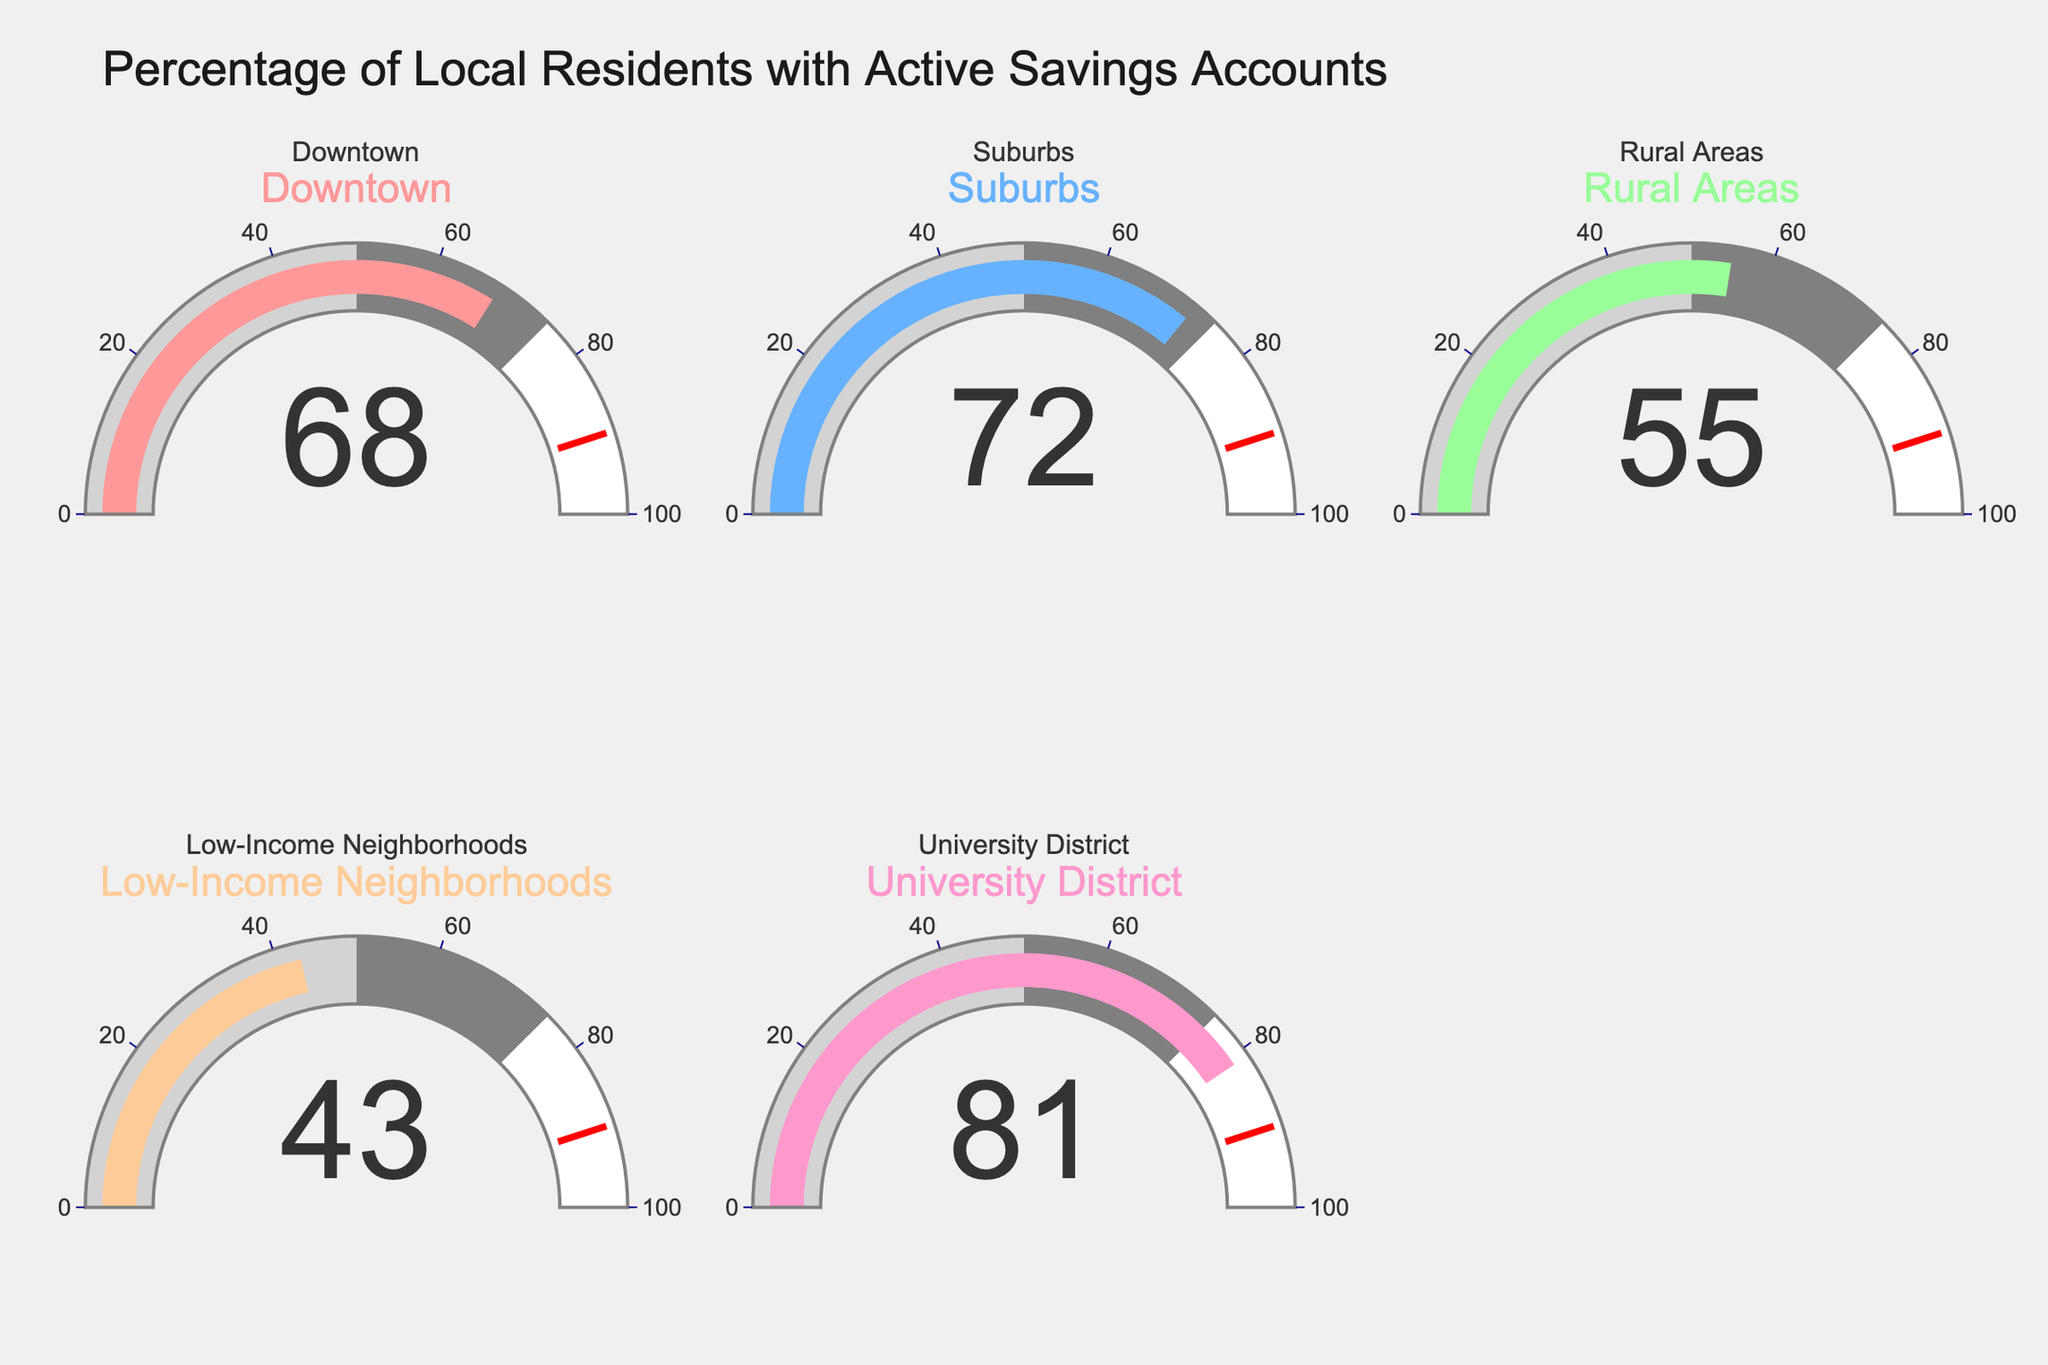What's the title of the figure? The title is located at the top of the figure, indicating the overall subject.
Answer: Percentage of Local Residents with Active Savings Accounts How many locations are displayed in the figure? We count the number of gauge charts, each representing a different location.
Answer: 5 Which location has the highest percentage of residents with active savings accounts? By examining each gauge's number, we compare all values to identify the highest one.
Answer: University District What is the percentage of residents with active savings accounts in Rural Areas? Look at the gauge corresponding to Rural Areas and read the number.
Answer: 55 What is the difference in percentage of active savings accounts between the Suburbs and Downtown? Subtract the percentage value of Downtown from that of the Suburbs.
Answer: 4 Which location has the lowest percentage of residents with active savings accounts? Compare all values on the gauges and identify the lowest one.
Answer: Low-Income Neighborhoods What is the average percentage of residents with active savings accounts across all locations? Sum all percentages and divide by the number of locations. (68 + 72 + 55 + 43 + 81) / 5 = 319 / 5 = 63.8
Answer: 63.8 How does the percentage in Low-Income Neighborhoods compare to the average percentage across all locations? Calculate the average percentage and compare it with the percentage in Low-Income Neighborhoods. (43 is less than 63.8)
Answer: Less What's the difference between the location with the highest and the location with the lowest percentage of active savings accounts? Subtract the lowest percentage from the highest percentage. 81 - 43 = 38
Answer: 38 How does the percentage in Downtown compare to that in the University District? Compare the percentage values directly from the gauges.
Answer: Lower 